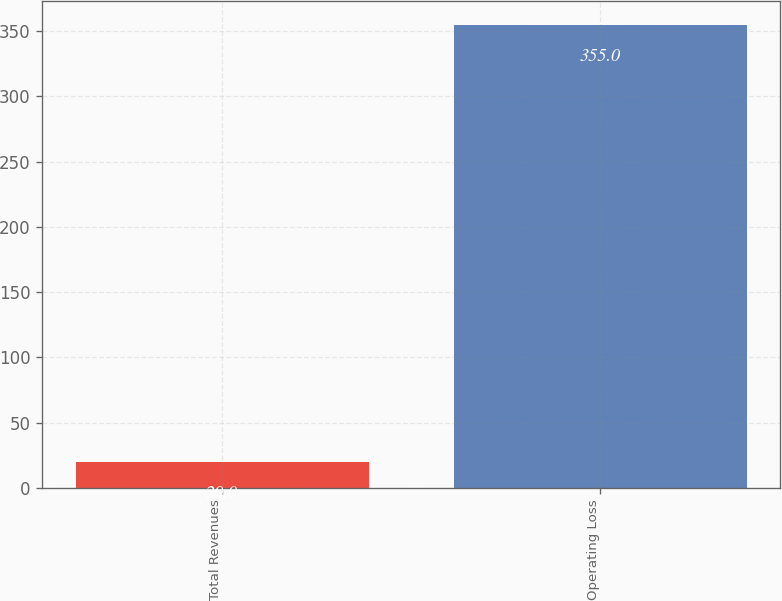<chart> <loc_0><loc_0><loc_500><loc_500><bar_chart><fcel>Total Revenues<fcel>Operating Loss<nl><fcel>20<fcel>355<nl></chart> 